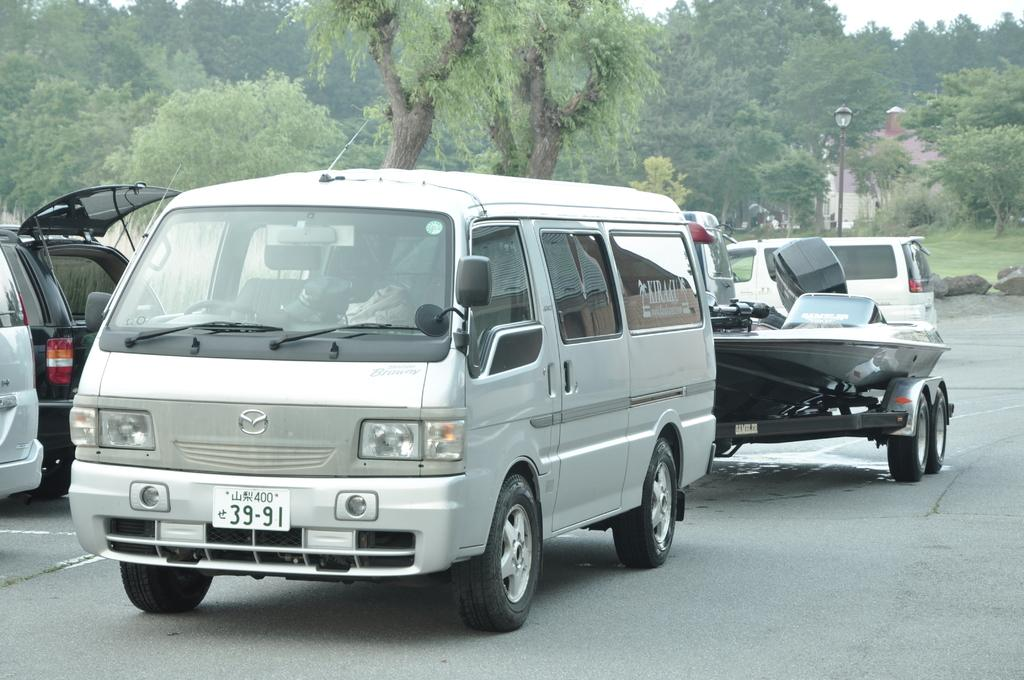Provide a one-sentence caption for the provided image. A white van with a plate number 39-19, tows a boat behind it. 